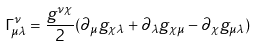<formula> <loc_0><loc_0><loc_500><loc_500>\Gamma ^ { \nu } _ { \mu \lambda } = \frac { g ^ { \nu \chi } } { 2 } ( \partial _ { \mu } g _ { \chi \lambda } + \partial _ { \lambda } g _ { \chi \mu } - \partial _ { \chi } g _ { \mu \lambda } )</formula> 